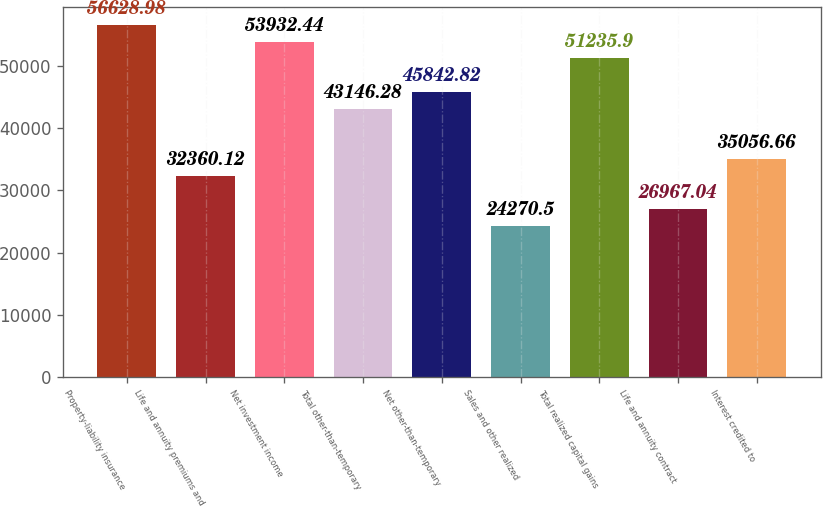Convert chart to OTSL. <chart><loc_0><loc_0><loc_500><loc_500><bar_chart><fcel>Property-liability insurance<fcel>Life and annuity premiums and<fcel>Net investment income<fcel>Total other-than-temporary<fcel>Net other-than-temporary<fcel>Sales and other realized<fcel>Total realized capital gains<fcel>Life and annuity contract<fcel>Interest credited to<nl><fcel>56629<fcel>32360.1<fcel>53932.4<fcel>43146.3<fcel>45842.8<fcel>24270.5<fcel>51235.9<fcel>26967<fcel>35056.7<nl></chart> 